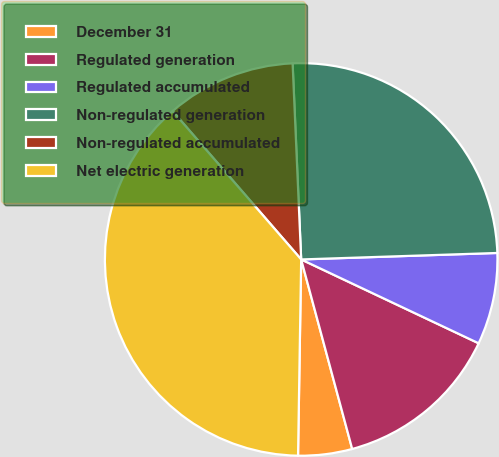<chart> <loc_0><loc_0><loc_500><loc_500><pie_chart><fcel>December 31<fcel>Regulated generation<fcel>Regulated accumulated<fcel>Non-regulated generation<fcel>Non-regulated accumulated<fcel>Net electric generation<nl><fcel>4.44%<fcel>13.79%<fcel>7.55%<fcel>25.17%<fcel>10.67%<fcel>38.38%<nl></chart> 